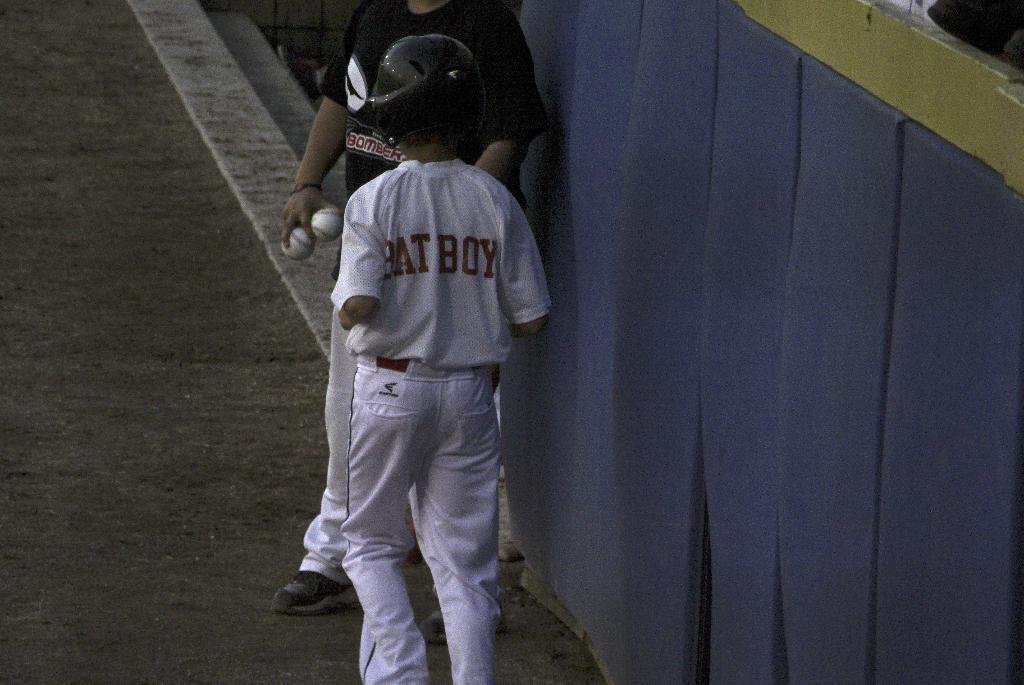Describe this image in one or two sentences. In this picture we can see two people on the ground, balls and some objects. 